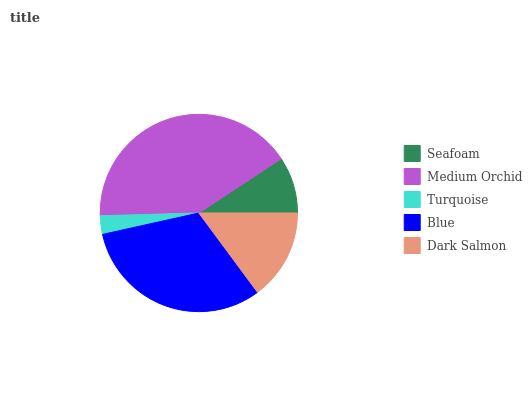Is Turquoise the minimum?
Answer yes or no. Yes. Is Medium Orchid the maximum?
Answer yes or no. Yes. Is Medium Orchid the minimum?
Answer yes or no. No. Is Turquoise the maximum?
Answer yes or no. No. Is Medium Orchid greater than Turquoise?
Answer yes or no. Yes. Is Turquoise less than Medium Orchid?
Answer yes or no. Yes. Is Turquoise greater than Medium Orchid?
Answer yes or no. No. Is Medium Orchid less than Turquoise?
Answer yes or no. No. Is Dark Salmon the high median?
Answer yes or no. Yes. Is Dark Salmon the low median?
Answer yes or no. Yes. Is Medium Orchid the high median?
Answer yes or no. No. Is Turquoise the low median?
Answer yes or no. No. 